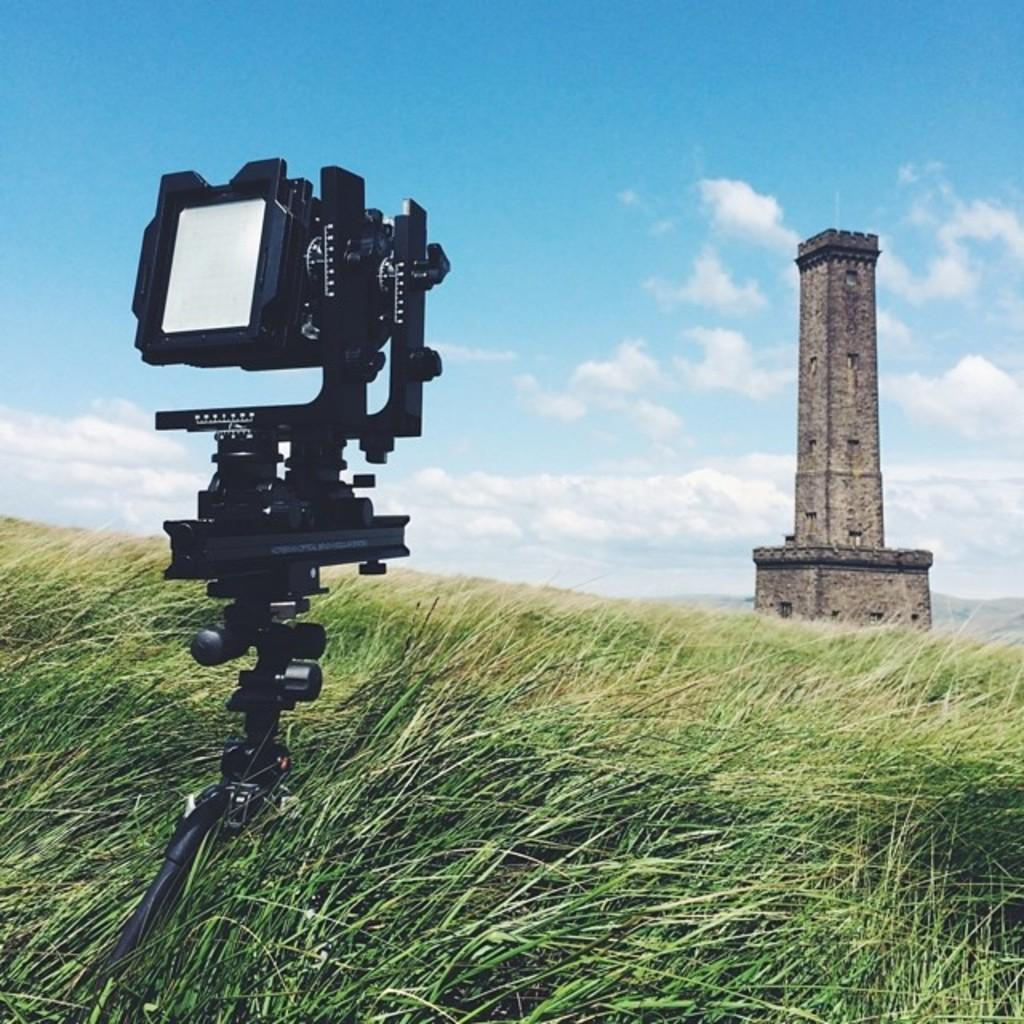What object can be seen in the image that is used for capturing photos? There is a camera in the image. What type of vegetation is present in the image? There is green grass in the image. What tall structure is visible in the image? There is a tower in the image. What colors can be seen in the sky in the image? The sky is in white and blue color in the image. Where is the mailbox located in the image? There is no mailbox present in the image. What type of wilderness can be seen in the image? There is no wilderness present in the image; it features green grass and a tower. Can you describe the stranger in the image? There is no stranger present in the image; it only features a camera, green grass, a tower, and a sky with white and blue colors. 